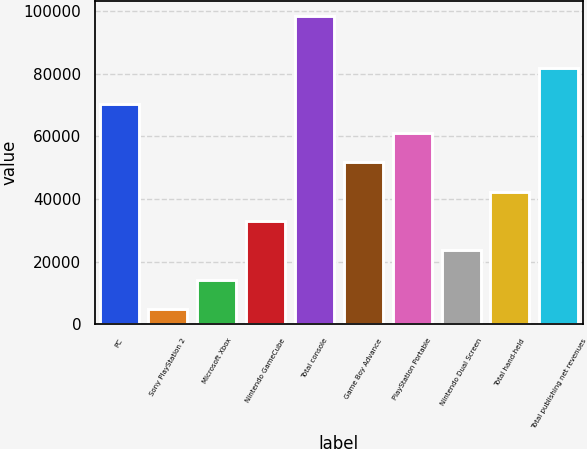Convert chart. <chart><loc_0><loc_0><loc_500><loc_500><bar_chart><fcel>PC<fcel>Sony PlayStation 2<fcel>Microsoft Xbox<fcel>Nintendo GameCube<fcel>Total console<fcel>Game Boy Advance<fcel>PlayStation Portable<fcel>Nintendo Dual Screen<fcel>Total hand-held<fcel>Total publishing net revenues<nl><fcel>70357.3<fcel>4929<fcel>14275.9<fcel>32969.7<fcel>98398<fcel>51663.5<fcel>61010.4<fcel>23622.8<fcel>42316.6<fcel>81934<nl></chart> 